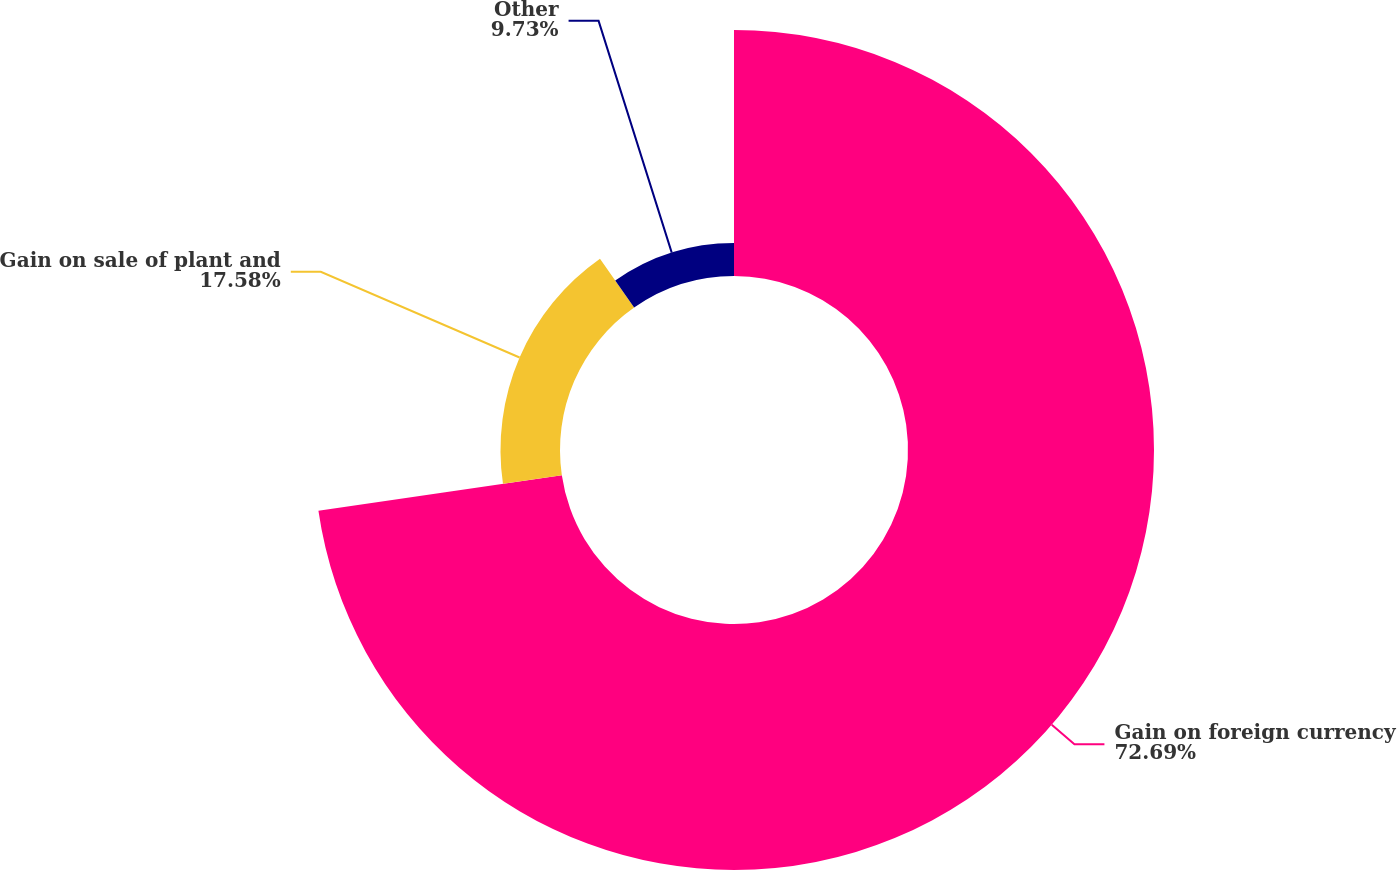Convert chart to OTSL. <chart><loc_0><loc_0><loc_500><loc_500><pie_chart><fcel>Gain on foreign currency<fcel>Gain on sale of plant and<fcel>Other<nl><fcel>72.69%<fcel>17.58%<fcel>9.73%<nl></chart> 